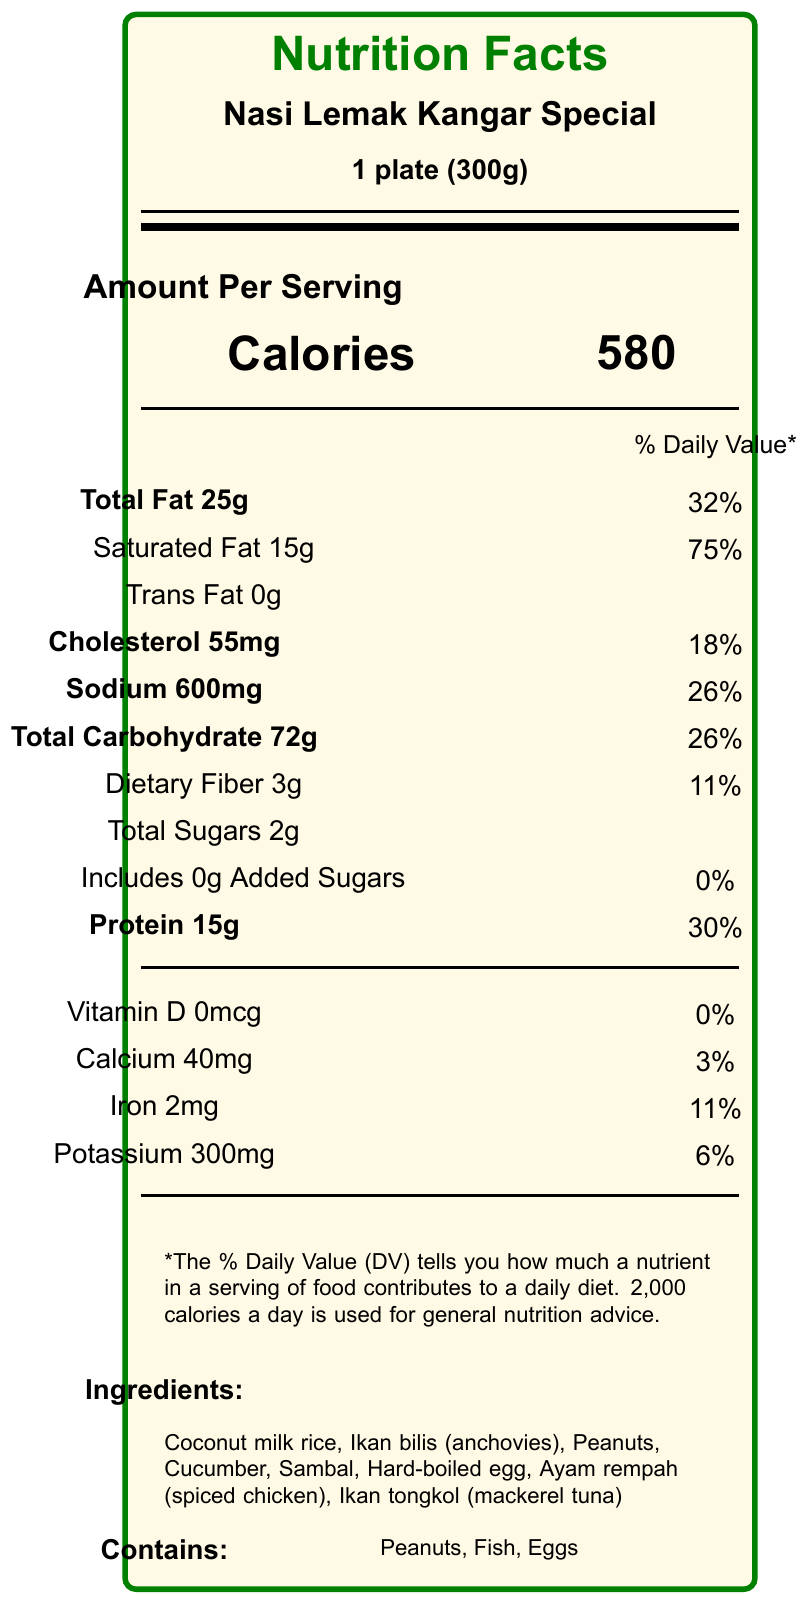What is the serving size of Nasi Lemak Kangar Special? The serving size is explicitly stated at the top of the nutritional facts under the product name.
Answer: 1 plate (300g) How many calories are there per serving? The number of calories per serving is listed prominently next to the word "Calories."
Answer: 580 What percentage of the daily value is the total fat content? The percentage of the daily value for total fat is listed next to the total fat amount, 25g, which is 32%.
Answer: 32% How much protein is in a serving of Nasi Lemak Kangar Special? The amount of protein per serving, 15g, is listed under the "Protein" section with a percentage of the daily value, 30%.
Answer: 15g What are the main ingredients of the dish? The ingredients list is provided at the bottom of the nutritional facts label.
Answer: Coconut milk rice, Ikan bilis (anchovies), Peanuts, Cucumber, Sambal, Hard-boiled egg, Ayam rempah (spiced chicken), Ikan tongkol (mackerel tuna) Which of the following nutrients is present in the highest percentage of the daily value? A. Cholesterol B. Sodium C. Saturated Fat D. Protein Saturated Fat is listed with a 75% daily value, which is the highest among the options provided.
Answer: C. Saturated Fat What allergens are contained in Nasi Lemak Kangar Special? A. Peanuts B. Fish C. Eggs D. Dairy The allergens listed are Peanuts, Fish, and Eggs; Dairy is not mentioned.
Answer: A. Peanuts B. Fish C. Eggs Does Nasi Lemak Kangar Special contain any added sugars? The label states "Includes 0g Added Sugars" and shows 0% daily value for added sugars.
Answer: No Does the document mention the source of the ingredients? The additional information section mentions that ingredients are sourced from Perlis farmers market.
Answer: Yes Summarize the main nutritional elements of Nasi Lemak Kangar Special. This summary encapsulates the main nutritional content, ingredient sourcing, and allergen information listed on the label.
Answer: Nasi Lemak Kangar Special has 580 calories per 1 plate (300g) serving. It contains 25g of total fat (32% DV), 15g of saturated fat (75% DV), 0g trans fat, 55mg of cholesterol (18% DV), 600mg of sodium (26% DV), 72g of total carbohydrates (26% DV), 3g of dietary fiber (11% DV), 2g of total sugars, and 15g of protein (30% DV). It is sourced locally and includes ingredients like coconut milk rice, ikan bilis, peanuts, cucumber, sambal, a hard-boiled egg, ayam rempah, and ikan tongkol, and contains allergens such as peanuts, fish, and eggs. What is the spiciness level of Nasi Lemak Kangar Special? The spiciness level is mentioned in the additional information section as "Medium".
Answer: Medium How much calcium does a serving of Nasi Lemak Kangar Special contain? The calcium content is listed at 40mg with a daily value percentage of 3%.
Answer: 40mg Is Nasi Lemak Kangar Special suitable for someone with a peanut allergy? The document lists peanuts as one of the ingredients, making it unsuitable for someone with a peanut allergy.
Answer: No What additional drink is suggested with Nasi Lemak Kangar Special? The traditional drink suggested is Teh Tarik, as stated in the additional information.
Answer: Teh Tarik How many grams of dietary fiber are in a serving? The amount of dietary fiber per serving has been specified as 3g.
Answer: 3g How much vitamin D does this dish provide? The label indicates 0mcg of vitamin D, contributing 0% to the daily value.
Answer: 0mcg Which of the following nutrients does this document show having the lowest daily value percentage? A. Potassium B. Iron C. Calcium D. Vitamin D The Vitamin D content is 0mcg, contributing 0% to the daily value.
Answer: D. Vitamin D Does the document provide any information about the environmental footprint of the ingredients? The document does not mention anything about the environmental footprint of the ingredients; it only mentions they are sourced from Perlis farmers market.
Answer: Not enough information 